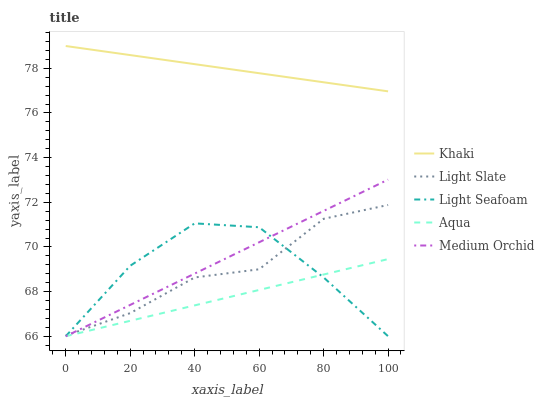Does Aqua have the minimum area under the curve?
Answer yes or no. Yes. Does Khaki have the maximum area under the curve?
Answer yes or no. Yes. Does Medium Orchid have the minimum area under the curve?
Answer yes or no. No. Does Medium Orchid have the maximum area under the curve?
Answer yes or no. No. Is Khaki the smoothest?
Answer yes or no. Yes. Is Light Seafoam the roughest?
Answer yes or no. Yes. Is Medium Orchid the smoothest?
Answer yes or no. No. Is Medium Orchid the roughest?
Answer yes or no. No. Does Medium Orchid have the lowest value?
Answer yes or no. Yes. Does Khaki have the lowest value?
Answer yes or no. No. Does Khaki have the highest value?
Answer yes or no. Yes. Does Medium Orchid have the highest value?
Answer yes or no. No. Is Light Seafoam less than Khaki?
Answer yes or no. Yes. Is Khaki greater than Medium Orchid?
Answer yes or no. Yes. Does Medium Orchid intersect Aqua?
Answer yes or no. Yes. Is Medium Orchid less than Aqua?
Answer yes or no. No. Is Medium Orchid greater than Aqua?
Answer yes or no. No. Does Light Seafoam intersect Khaki?
Answer yes or no. No. 